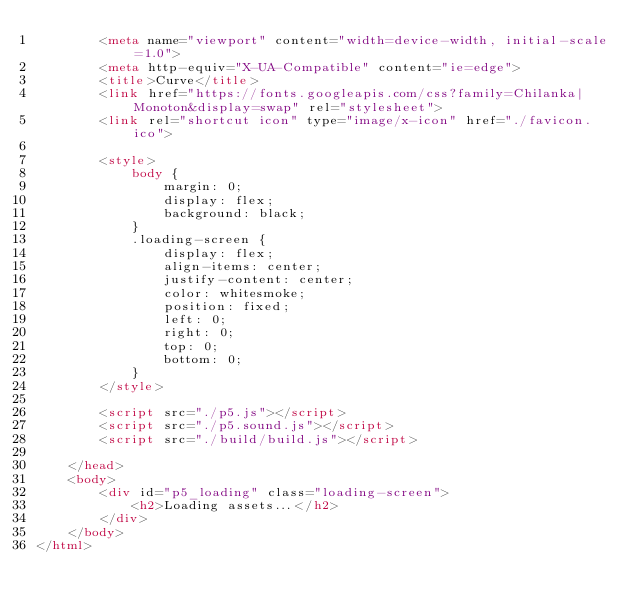Convert code to text. <code><loc_0><loc_0><loc_500><loc_500><_HTML_>        <meta name="viewport" content="width=device-width, initial-scale=1.0">
        <meta http-equiv="X-UA-Compatible" content="ie=edge">
        <title>Curve</title>
        <link href="https://fonts.googleapis.com/css?family=Chilanka|Monoton&display=swap" rel="stylesheet">
        <link rel="shortcut icon" type="image/x-icon" href="./favicon.ico">

        <style>
            body {
                margin: 0;
                display: flex;
                background: black;
            }
            .loading-screen {
                display: flex;
                align-items: center;
                justify-content: center;
                color: whitesmoke;
                position: fixed;
                left: 0;
                right: 0;
                top: 0;
                bottom: 0;
            }
        </style>

        <script src="./p5.js"></script>
        <script src="./p5.sound.js"></script>
        <script src="./build/build.js"></script>

    </head>
    <body>
        <div id="p5_loading" class="loading-screen">
            <h2>Loading assets...</h2>
        </div>
    </body>
</html></code> 